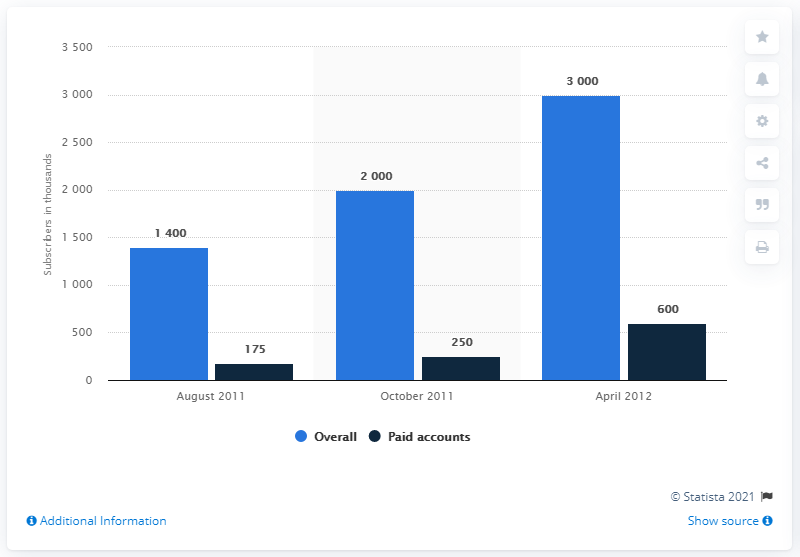Give some essential details in this illustration. As of August 2011, the average overall and paid subscriber numbers in the U.S. were approximately 787.5. As of August 2011, the overall number of subscribers in the US was approximately 1400. 